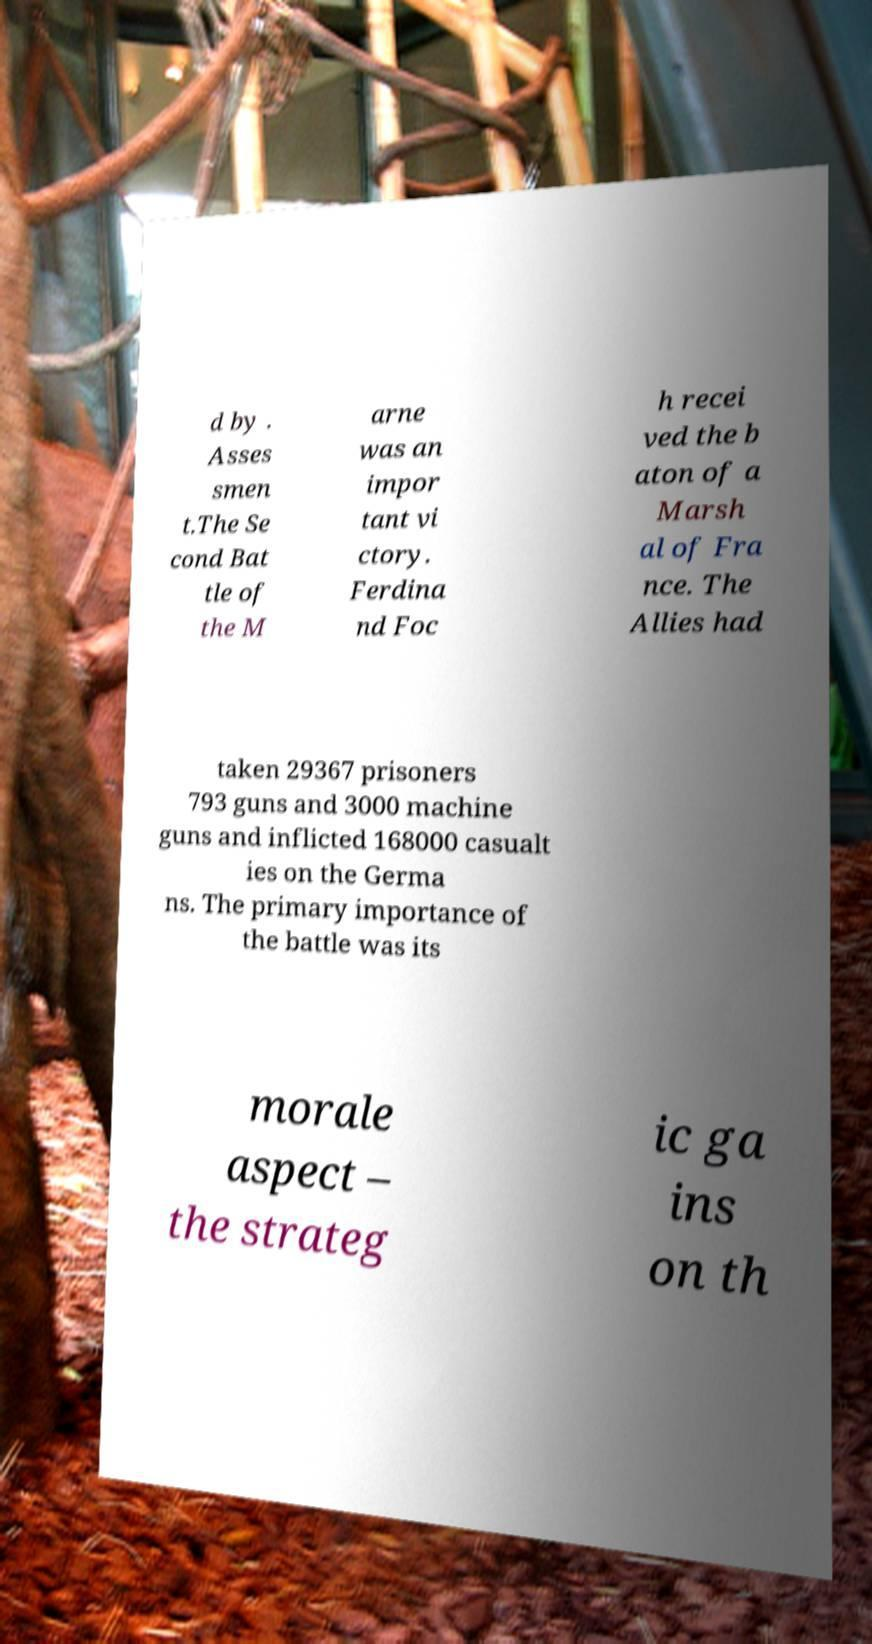Could you assist in decoding the text presented in this image and type it out clearly? d by . Asses smen t.The Se cond Bat tle of the M arne was an impor tant vi ctory. Ferdina nd Foc h recei ved the b aton of a Marsh al of Fra nce. The Allies had taken 29367 prisoners 793 guns and 3000 machine guns and inflicted 168000 casualt ies on the Germa ns. The primary importance of the battle was its morale aspect – the strateg ic ga ins on th 